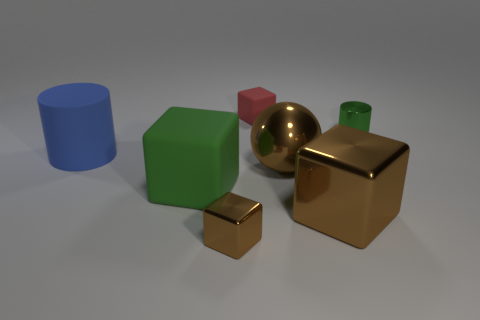There is a big brown metallic object that is left of the large metal cube; is it the same shape as the small matte object?
Ensure brevity in your answer.  No. There is a small thing that is the same color as the large matte cube; what is its material?
Offer a terse response. Metal. How many other cubes have the same color as the large metal cube?
Your answer should be compact. 1. What is the shape of the blue matte object in front of the rubber object behind the large blue matte cylinder?
Ensure brevity in your answer.  Cylinder. Is there a big green rubber object of the same shape as the tiny red matte object?
Your answer should be very brief. Yes. There is a big rubber cylinder; is its color the same as the tiny metal thing that is in front of the tiny green shiny thing?
Offer a terse response. No. What is the size of the shiny ball that is the same color as the big metallic block?
Your answer should be compact. Large. Is there a cyan metal thing of the same size as the shiny ball?
Provide a succinct answer. No. Is the small green cylinder made of the same material as the small thing that is in front of the brown ball?
Make the answer very short. Yes. Is the number of small metal cylinders greater than the number of big gray objects?
Provide a short and direct response. Yes. 